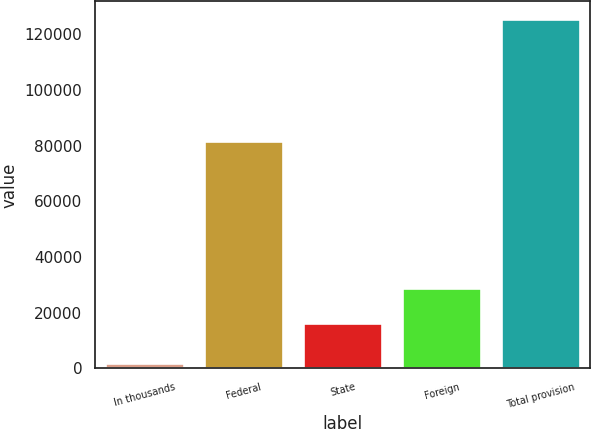<chart> <loc_0><loc_0><loc_500><loc_500><bar_chart><fcel>In thousands<fcel>Federal<fcel>State<fcel>Foreign<fcel>Total provision<nl><fcel>2012<fcel>81630<fcel>16415<fcel>28776.4<fcel>125626<nl></chart> 